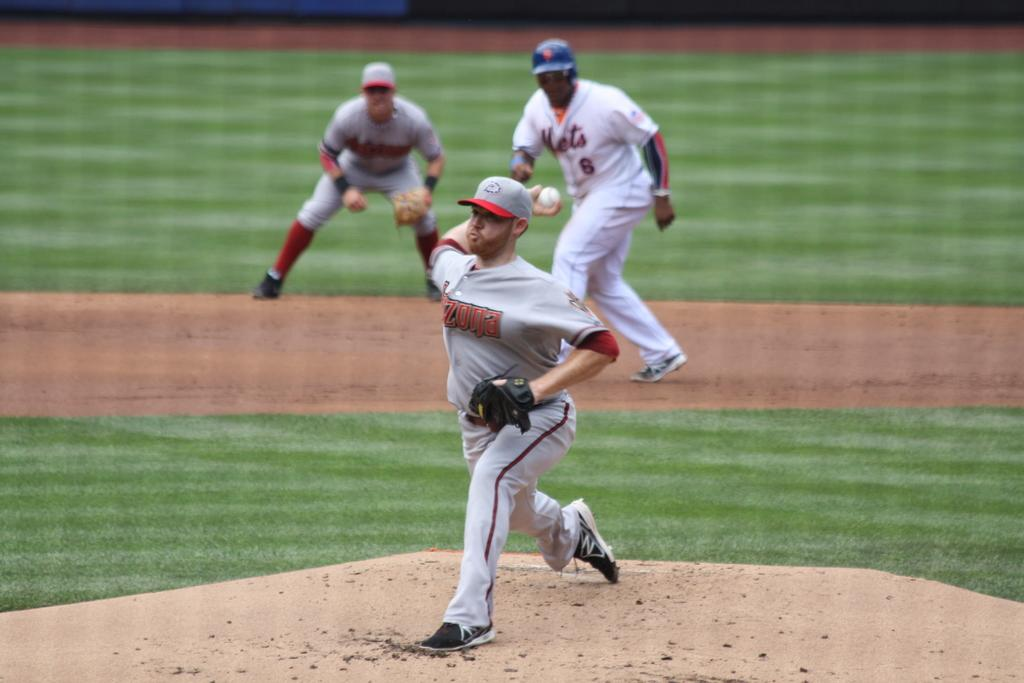<image>
Summarize the visual content of the image. Player 6 from the Mets prepares to run as the pitcher prepares to throw the ball. 